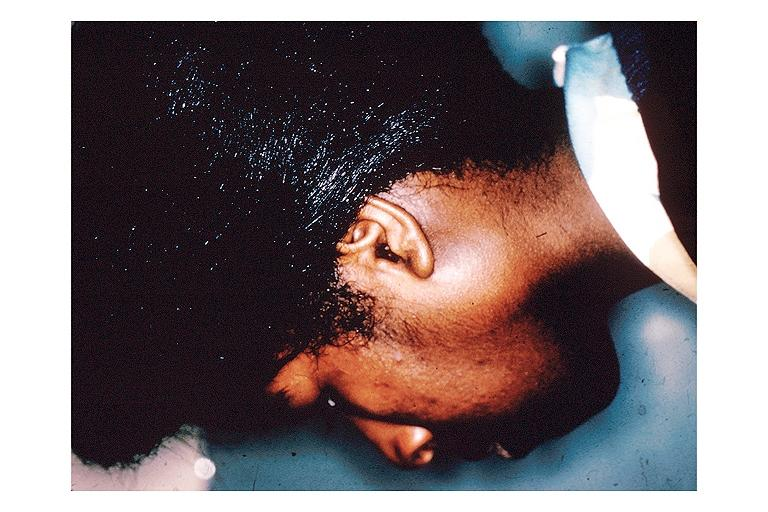s stein leventhal present?
Answer the question using a single word or phrase. No 